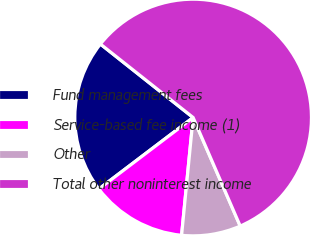Convert chart. <chart><loc_0><loc_0><loc_500><loc_500><pie_chart><fcel>Fund management fees<fcel>Service-based fee income (1)<fcel>Other<fcel>Total other noninterest income<nl><fcel>20.99%<fcel>13.12%<fcel>8.07%<fcel>57.82%<nl></chart> 